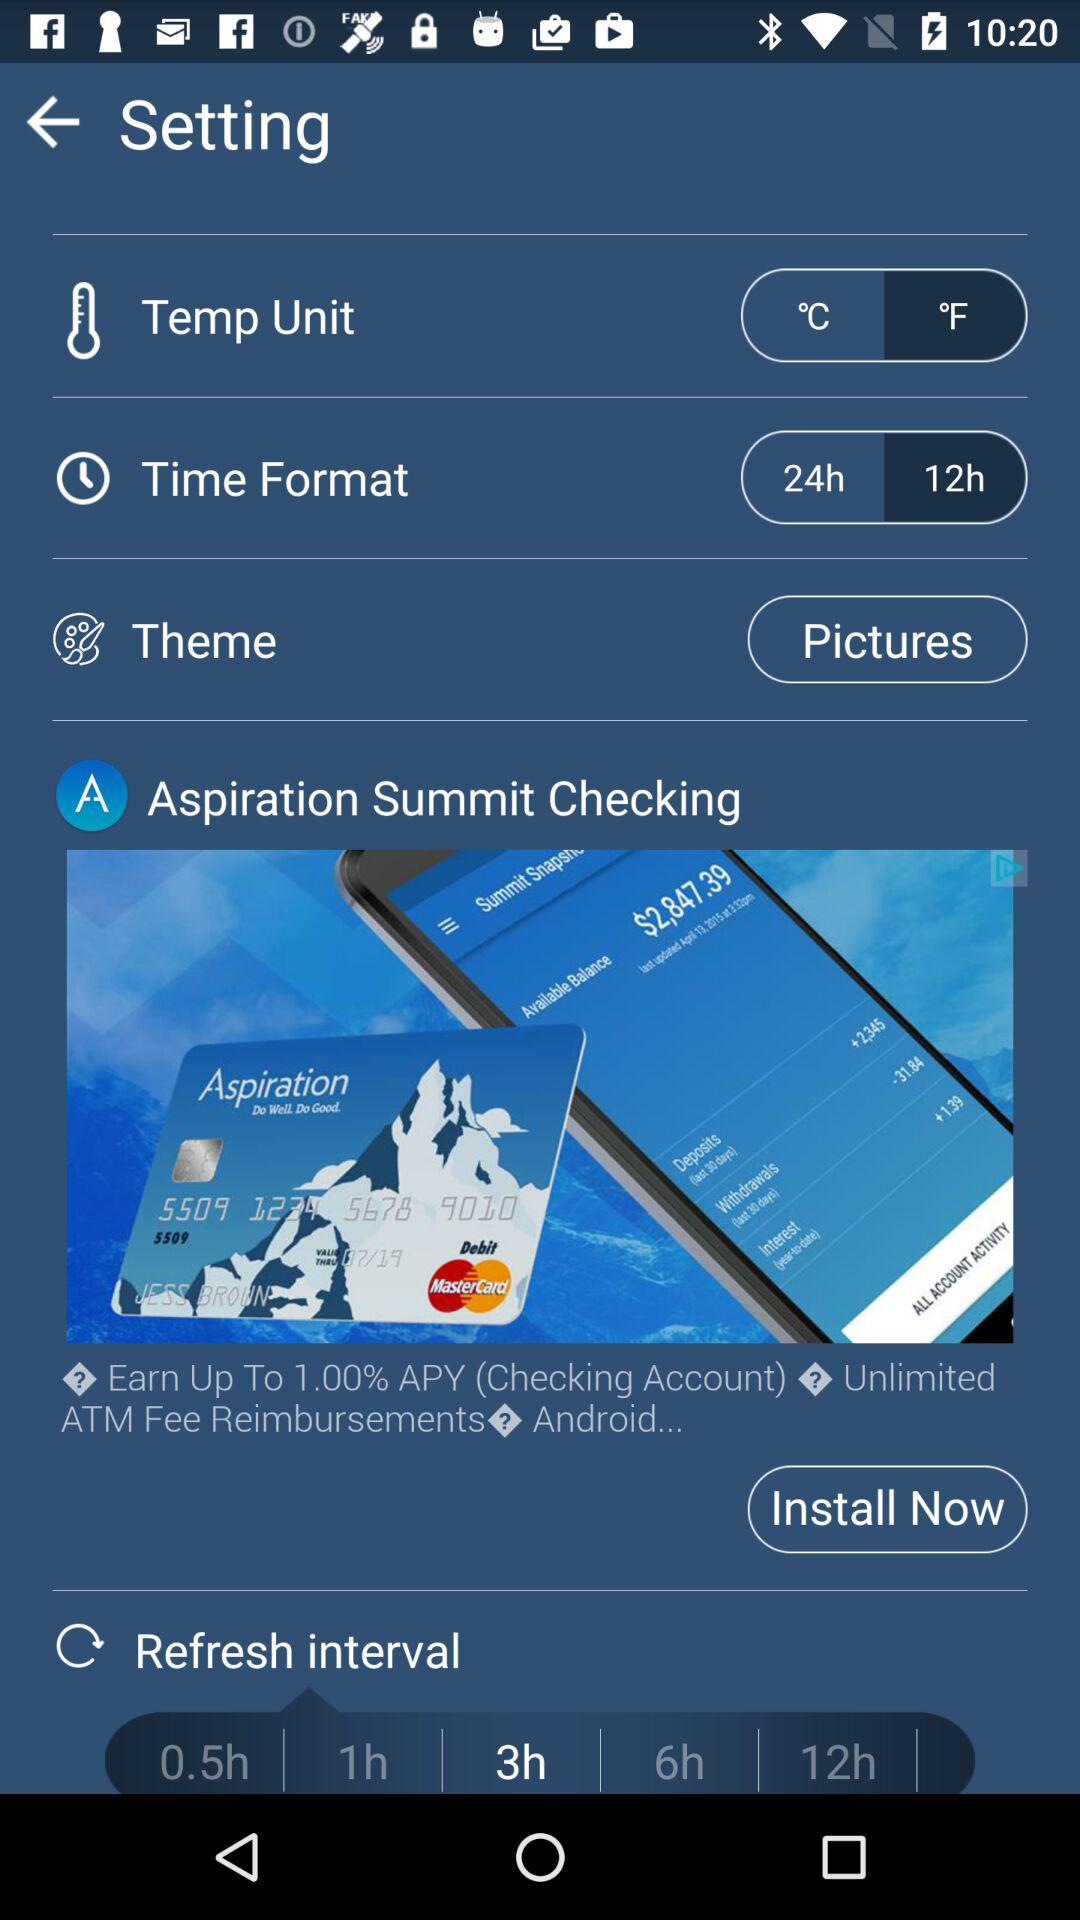Which time format is selected? The selected time format is 12 hours. 